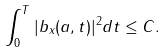Convert formula to latex. <formula><loc_0><loc_0><loc_500><loc_500>\int _ { 0 } ^ { T } | b _ { x } ( a , t ) | ^ { 2 } d t \leq C .</formula> 